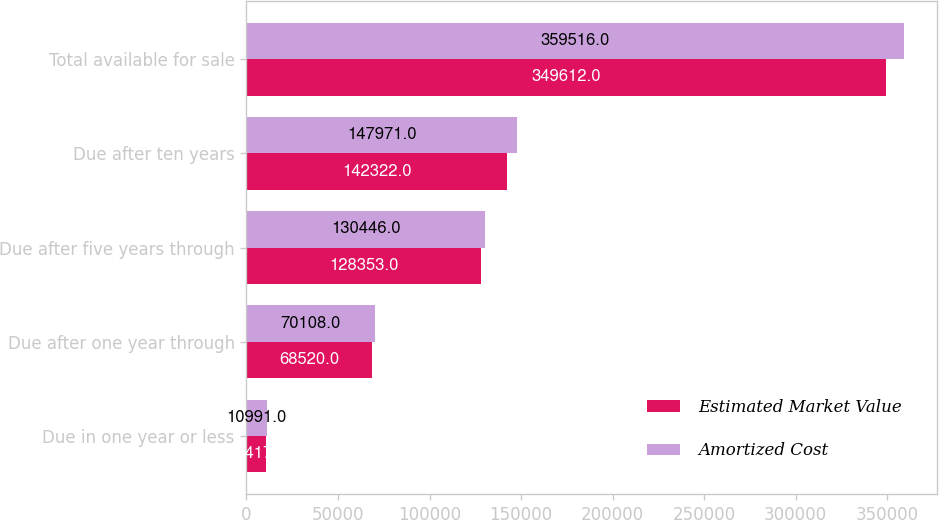<chart> <loc_0><loc_0><loc_500><loc_500><stacked_bar_chart><ecel><fcel>Due in one year or less<fcel>Due after one year through<fcel>Due after five years through<fcel>Due after ten years<fcel>Total available for sale<nl><fcel>Estimated Market Value<fcel>10417<fcel>68520<fcel>128353<fcel>142322<fcel>349612<nl><fcel>Amortized Cost<fcel>10991<fcel>70108<fcel>130446<fcel>147971<fcel>359516<nl></chart> 